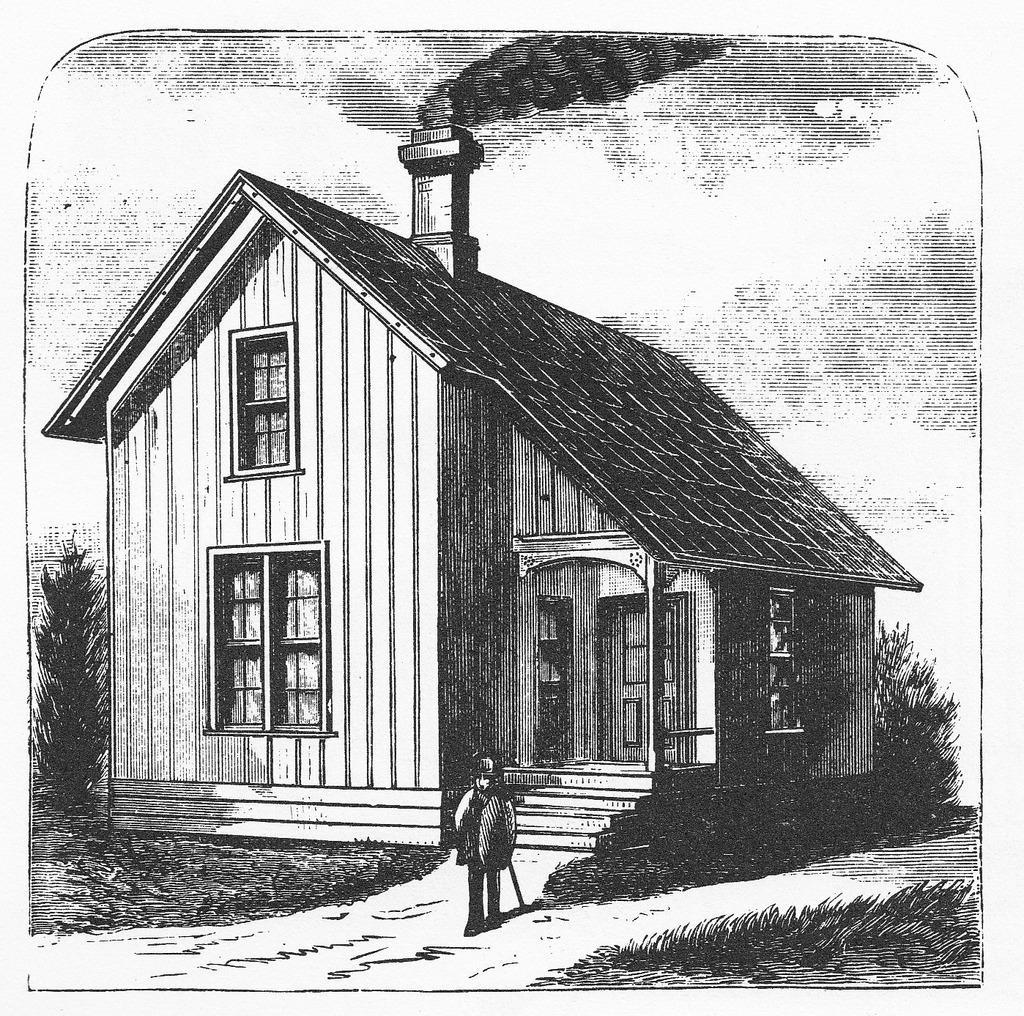Could you give a brief overview of what you see in this image? In this image we can see drawings of a person, house, doors, windows, plants, smoke and clouds in the sky. 